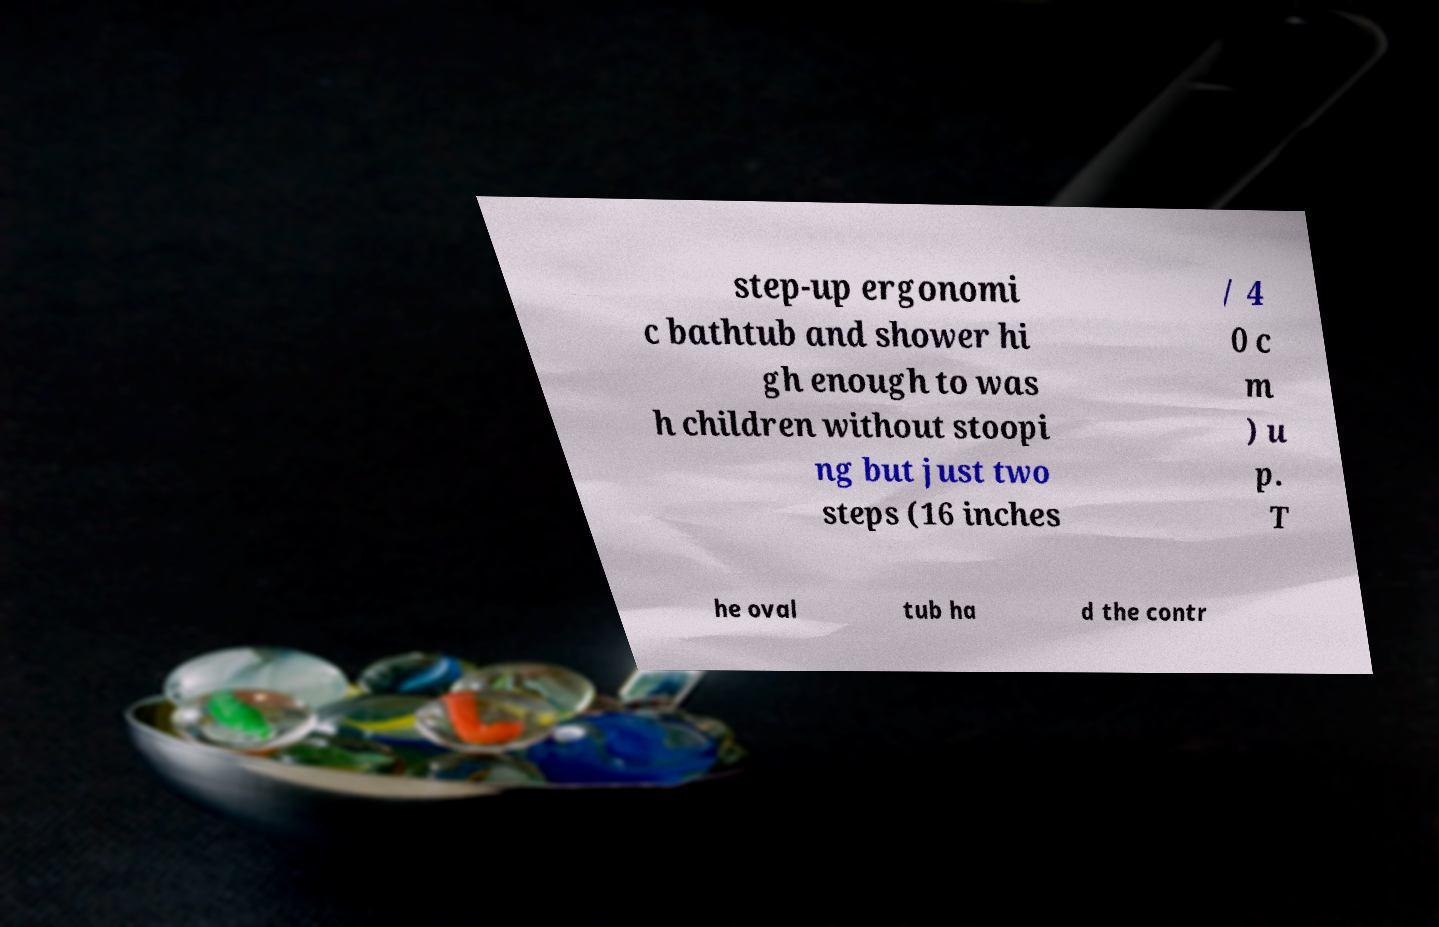Please identify and transcribe the text found in this image. step-up ergonomi c bathtub and shower hi gh enough to was h children without stoopi ng but just two steps (16 inches / 4 0 c m ) u p. T he oval tub ha d the contr 